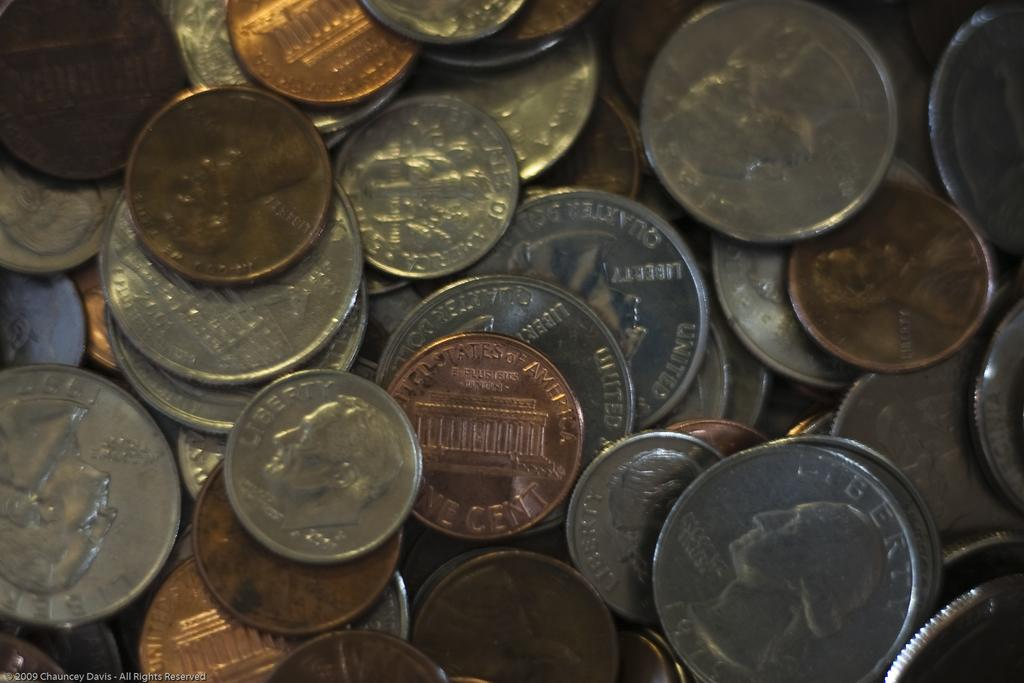<image>
Describe the image concisely. A collection of U.S. coins including One Cent pieces and quarters sit on a table. 